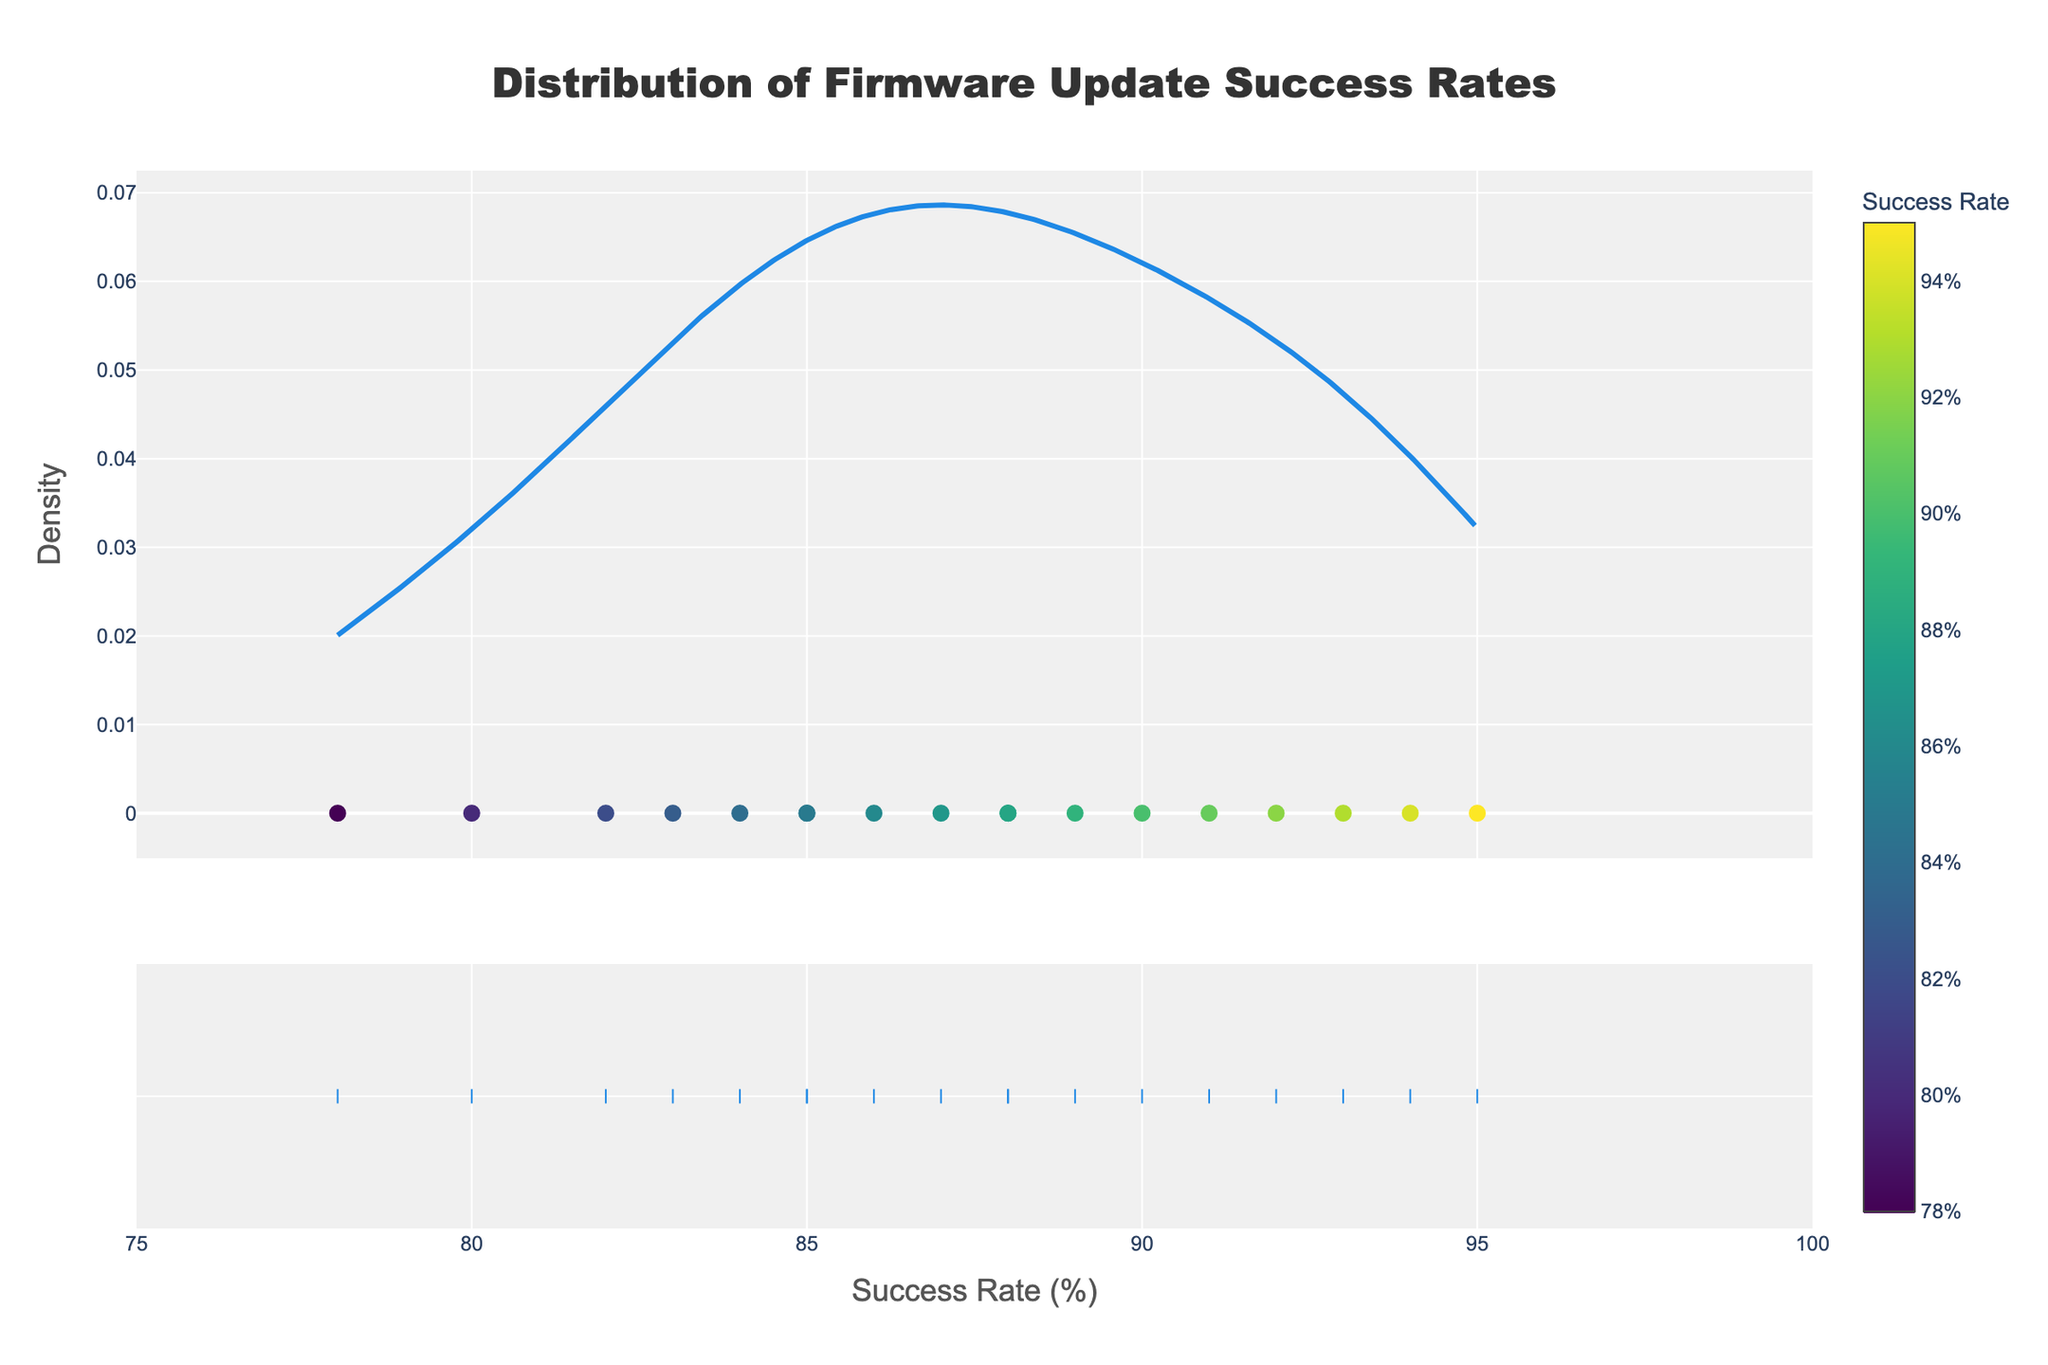What is the title of the figure? The title is located at the top of the figure and reads "Distribution of Firmware Update Success Rates".
Answer: Distribution of Firmware Update Success Rates What is the range of success rates displayed on the x-axis? The x-axis represents the success rates, the range is shown from 75% to 100%.
Answer: 75% to 100% How many security devices have their success rates marked on the figure? Each device's success rate is marked with a scatter point. By counting these scatter markers, you can determine the number of devices, which is 18.
Answer: 18 What is the highest success rate observed in the dataset? The scatter plot includes markers that show individual success rates. The highest point is identified as 95%.
Answer: 95% What is shown on the y-axis of the figure? The y-axis represents density, which is standard for distplots to show the distribution of data.
Answer: Density Which device has the lowest success rate and what is that rate? By looking at the scatter plot markers' positions, the lowest success rate is 78% for CCTV_Camera_Model_Y530.
Answer: CCTV_Camera_Model_Y530, 78% Does the figure show a color bar? If so, what does it represent? Yes, there is a color bar next to the scatter points. It represents the success rate in percentage.
Answer: Yes, success rate in percentage What does the central tendency of the distribution look like? The central tendency in a distplot is indicated by the peak(s) in the density plot. Here, it appears around the success rate range of 85-90%.
Answer: 85-90% Is there a color variation among the scatter points? If yes, what does it signify? Yes, scatter points have varying colors ranging from the color bar, which signifies different success rates among the devices.
Answer: Yes, different success rates How many devices have a success rate above 90%? Count the scatter points positioned at or above the 90% mark on the x-axis. There are 7 such devices.
Answer: 7 